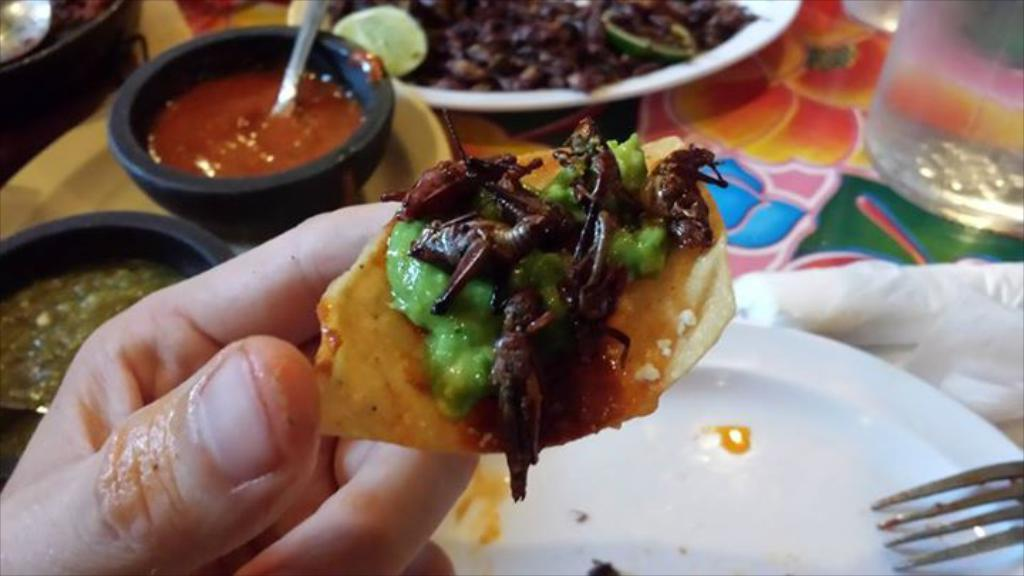What type of containers are holding food items in the image? There are bowls and plates holding food items in the image. What can be seen on the left side of the image? There is a hand of a person on the left side of the image. What utensil is visible on the right side of the image? There is a fork on the right side of the image. What type of skirt is being worn by the person in the image? There is no person wearing a skirt in the image; only a hand is visible on the left side. Can you see a rifle in the image? There is no rifle present in the image. 